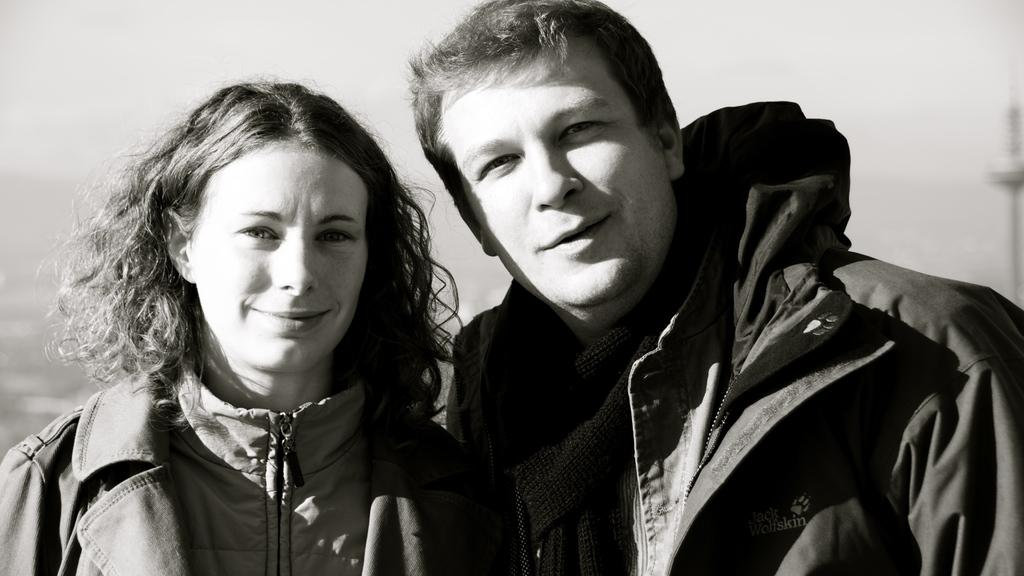How many people are in the image? There are two persons in the image. What are the two persons doing in the image? The two persons are standing. What expressions do the two persons have in the image? The two persons are smiling. What is the color scheme of the image? The image is in black and white. What type of brush can be seen in the hands of the two persons in the image? There is no brush present in the image; the two persons are simply standing and smiling. 